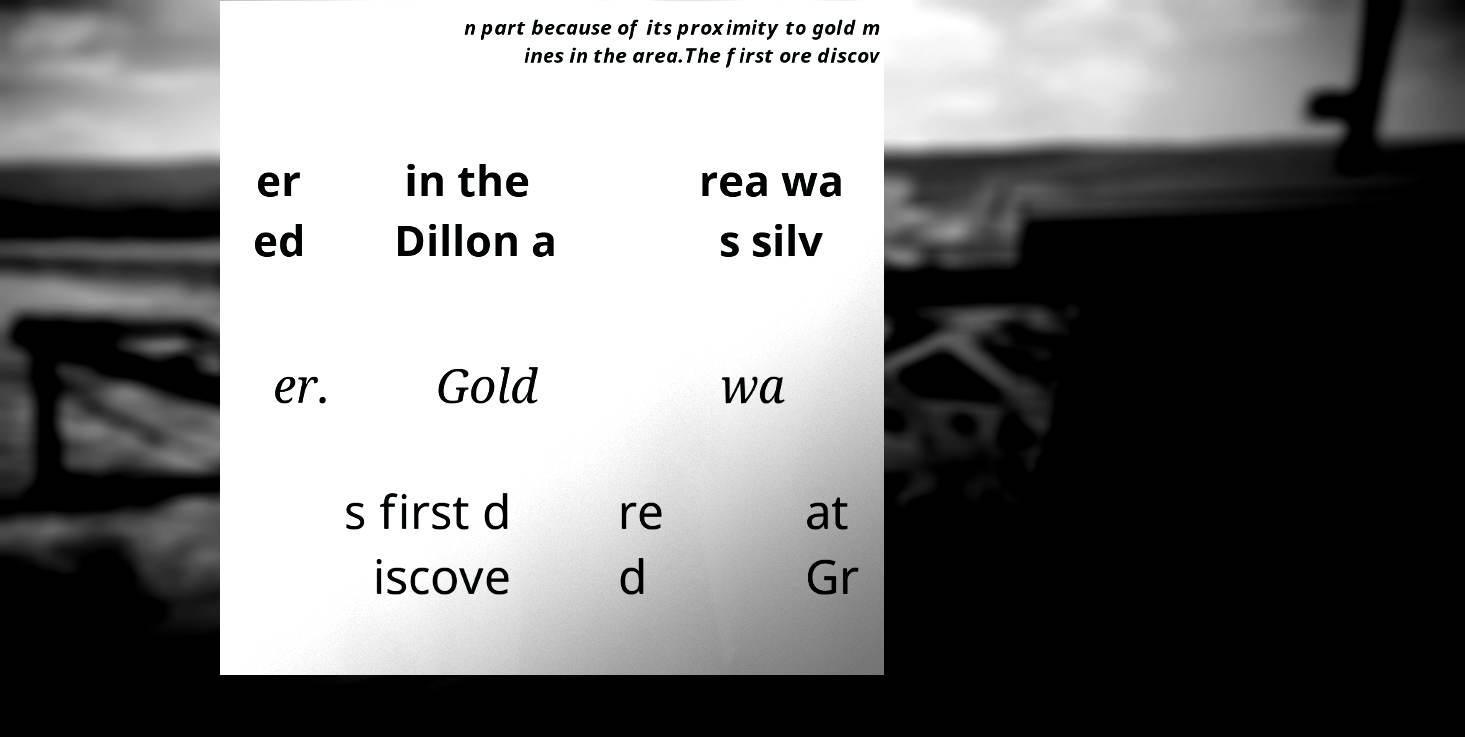For documentation purposes, I need the text within this image transcribed. Could you provide that? n part because of its proximity to gold m ines in the area.The first ore discov er ed in the Dillon a rea wa s silv er. Gold wa s first d iscove re d at Gr 